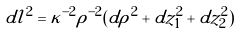<formula> <loc_0><loc_0><loc_500><loc_500>d l ^ { 2 } = \kappa ^ { - 2 } \rho ^ { - 2 } ( d \rho ^ { 2 } + d z _ { 1 } ^ { 2 } + d z _ { 2 } ^ { 2 } )</formula> 